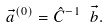Convert formula to latex. <formula><loc_0><loc_0><loc_500><loc_500>\vec { a } ^ { ( 0 ) } = { \hat { C } } ^ { - 1 } \text { } \vec { b } .</formula> 